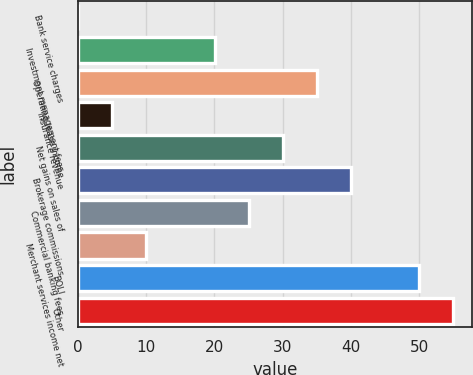Convert chart. <chart><loc_0><loc_0><loc_500><loc_500><bar_chart><fcel>Bank service charges<fcel>Investment management fees<fcel>Operating lease income<fcel>Insurance revenue<fcel>Net gains on sales of<fcel>Brokerage commissions<fcel>Commercial banking fees<fcel>Merchant services income net<fcel>BOLI<fcel>Other<nl><fcel>0.1<fcel>20.06<fcel>35.03<fcel>5.09<fcel>30.04<fcel>40.02<fcel>25.05<fcel>10.08<fcel>50<fcel>54.99<nl></chart> 